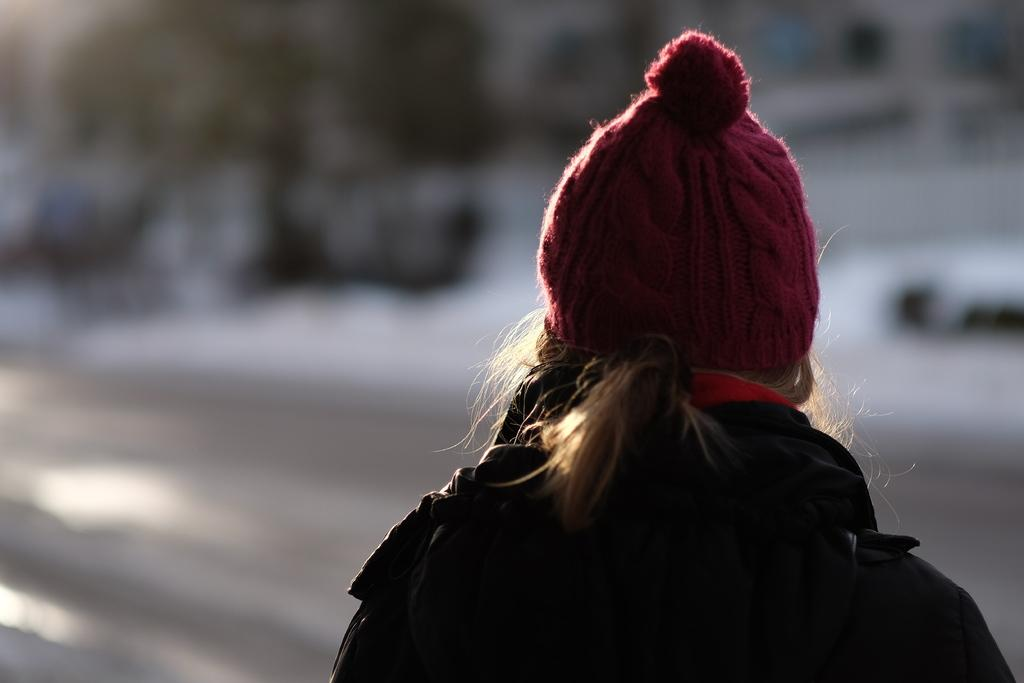Who is the main subject in the picture? There is a woman in the picture. What direction is the woman facing? The woman is facing backwards. What color is the jacket the woman is wearing? The woman is wearing a black jacket. What type of headwear is the woman wearing? The woman is wearing a red cap. Can you see a snake slithering around the woman's arm in the image? There is no snake present in the image. What type of hall can be seen in the background of the image? There is no hall visible in the image; it only features the woman. 